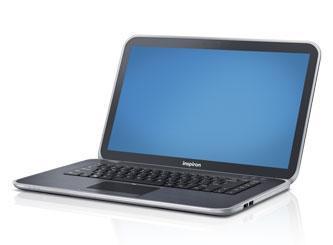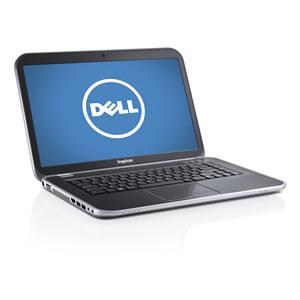The first image is the image on the left, the second image is the image on the right. Examine the images to the left and right. Is the description "the laptop on the right image has a black background" accurate? Answer yes or no. No. 